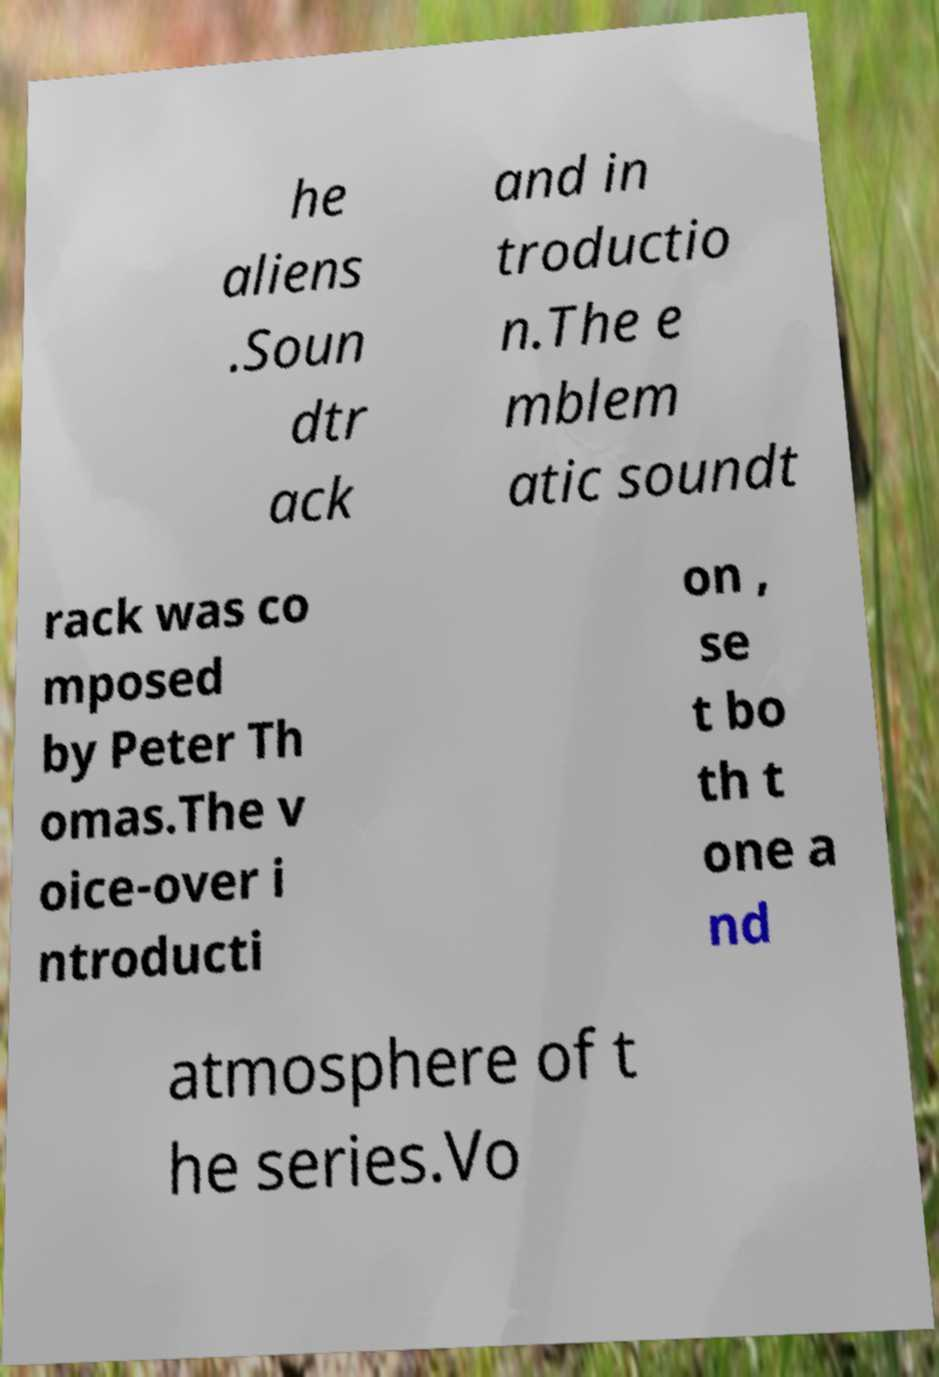Can you read and provide the text displayed in the image?This photo seems to have some interesting text. Can you extract and type it out for me? he aliens .Soun dtr ack and in troductio n.The e mblem atic soundt rack was co mposed by Peter Th omas.The v oice-over i ntroducti on , se t bo th t one a nd atmosphere of t he series.Vo 